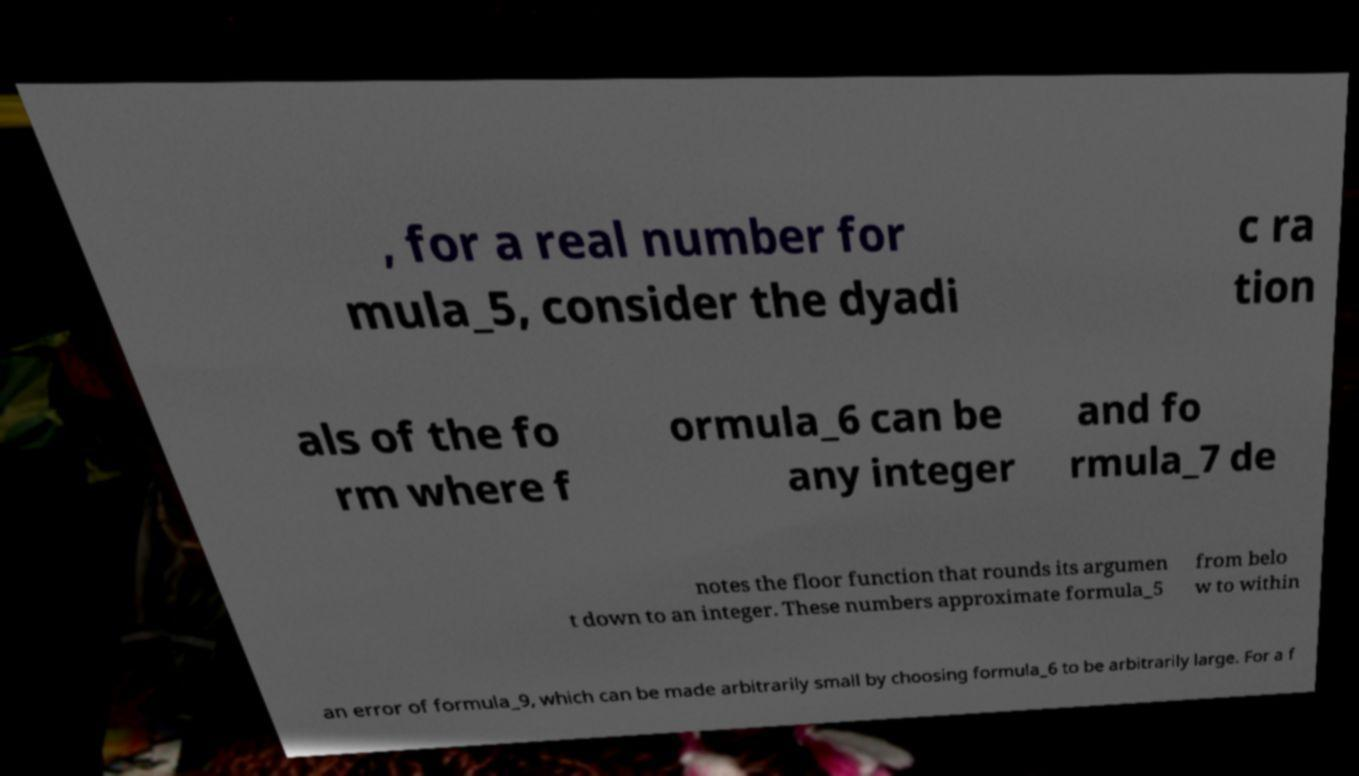Please read and relay the text visible in this image. What does it say? , for a real number for mula_5, consider the dyadi c ra tion als of the fo rm where f ormula_6 can be any integer and fo rmula_7 de notes the floor function that rounds its argumen t down to an integer. These numbers approximate formula_5 from belo w to within an error of formula_9, which can be made arbitrarily small by choosing formula_6 to be arbitrarily large. For a f 